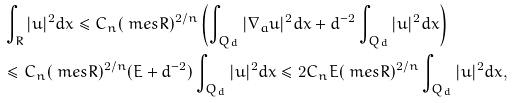<formula> <loc_0><loc_0><loc_500><loc_500>& \int _ { R } | u | ^ { 2 } d x \leq C _ { n } ( \ m e s R ) ^ { 2 / n } \left ( \int _ { Q _ { d } } | \nabla _ { a } u | ^ { 2 } d x + d ^ { - 2 } \int _ { Q _ { d } } | u | ^ { 2 } d x \right ) \\ & \leq C _ { n } ( \ m e s R ) ^ { 2 / n } ( E + d ^ { - 2 } ) \int _ { Q _ { d } } | u | ^ { 2 } d x \leq 2 C _ { n } E ( \ m e s R ) ^ { 2 / n } \int _ { Q _ { d } } | u | ^ { 2 } d x ,</formula> 